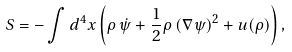Convert formula to latex. <formula><loc_0><loc_0><loc_500><loc_500>S = - \int d ^ { 4 } x \left ( \rho \, \dot { \psi } + \frac { 1 } { 2 } \rho \, ( \nabla \psi ) ^ { 2 } + u ( \rho ) \right ) ,</formula> 